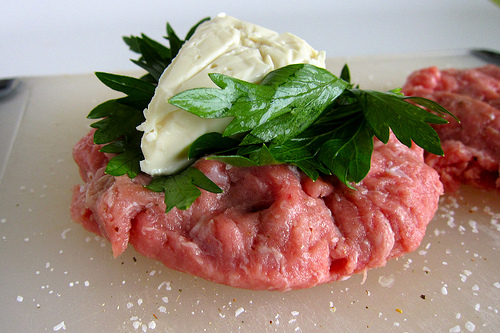<image>
Is the meat under the leaf? Yes. The meat is positioned underneath the leaf, with the leaf above it in the vertical space. 